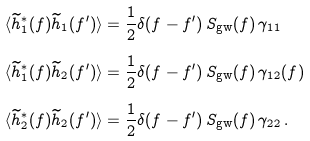<formula> <loc_0><loc_0><loc_500><loc_500>\langle \widetilde { h } _ { 1 } ^ { * } ( f ) \widetilde { h } _ { 1 } ( f ^ { \prime } ) \rangle & = \frac { 1 } { 2 } \delta ( f - f ^ { \prime } ) \, S _ { \text {gw} } ( f ) \, \gamma _ { 1 1 } \\ \langle \widetilde { h } _ { 1 } ^ { * } ( f ) \widetilde { h } _ { 2 } ( f ^ { \prime } ) \rangle & = \frac { 1 } { 2 } \delta ( f - f ^ { \prime } ) \, S _ { \text {gw} } ( f ) \, \gamma _ { 1 2 } ( f ) \\ \langle \widetilde { h } _ { 2 } ^ { * } ( f ) \widetilde { h } _ { 2 } ( f ^ { \prime } ) \rangle & = \frac { 1 } { 2 } \delta ( f - f ^ { \prime } ) \, S _ { \text {gw} } ( f ) \, \gamma _ { 2 2 } \, .</formula> 